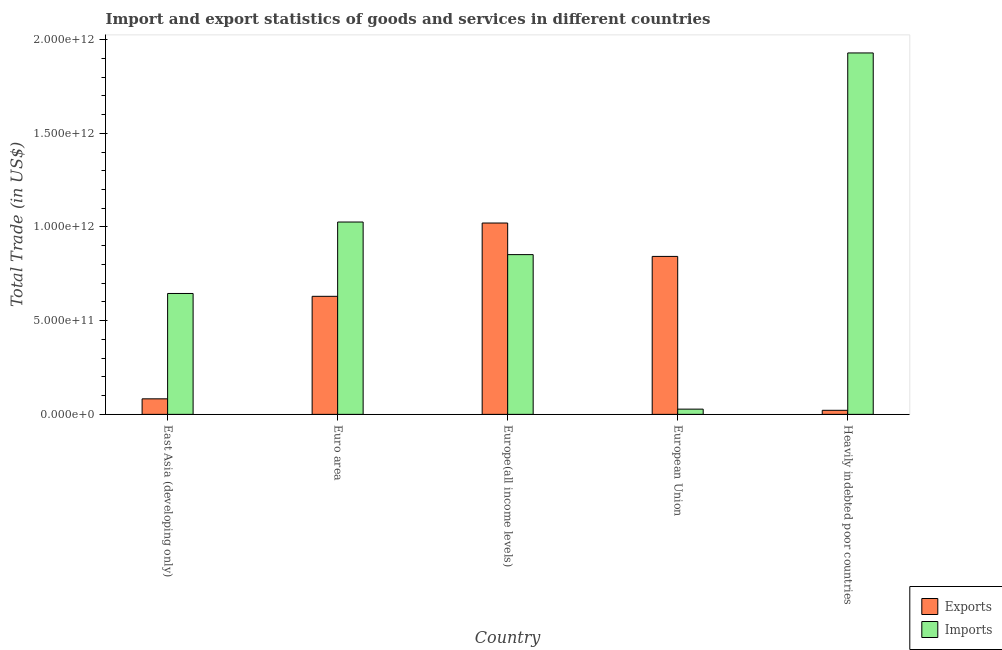How many groups of bars are there?
Ensure brevity in your answer.  5. Are the number of bars on each tick of the X-axis equal?
Your response must be concise. Yes. How many bars are there on the 4th tick from the left?
Keep it short and to the point. 2. How many bars are there on the 5th tick from the right?
Give a very brief answer. 2. In how many cases, is the number of bars for a given country not equal to the number of legend labels?
Ensure brevity in your answer.  0. What is the export of goods and services in Heavily indebted poor countries?
Ensure brevity in your answer.  2.17e+1. Across all countries, what is the maximum imports of goods and services?
Ensure brevity in your answer.  1.93e+12. Across all countries, what is the minimum export of goods and services?
Your answer should be very brief. 2.17e+1. In which country was the export of goods and services maximum?
Keep it short and to the point. Europe(all income levels). In which country was the export of goods and services minimum?
Offer a very short reply. Heavily indebted poor countries. What is the total export of goods and services in the graph?
Ensure brevity in your answer.  2.60e+12. What is the difference between the imports of goods and services in Euro area and that in Europe(all income levels)?
Your answer should be compact. 1.74e+11. What is the difference between the export of goods and services in East Asia (developing only) and the imports of goods and services in Europe(all income levels)?
Your response must be concise. -7.70e+11. What is the average imports of goods and services per country?
Provide a succinct answer. 8.96e+11. What is the difference between the export of goods and services and imports of goods and services in East Asia (developing only)?
Give a very brief answer. -5.62e+11. In how many countries, is the imports of goods and services greater than 1400000000000 US$?
Your answer should be very brief. 1. What is the ratio of the imports of goods and services in Euro area to that in European Union?
Your answer should be very brief. 36.71. Is the imports of goods and services in East Asia (developing only) less than that in Heavily indebted poor countries?
Your answer should be compact. Yes. Is the difference between the export of goods and services in European Union and Heavily indebted poor countries greater than the difference between the imports of goods and services in European Union and Heavily indebted poor countries?
Your answer should be compact. Yes. What is the difference between the highest and the second highest imports of goods and services?
Offer a very short reply. 9.02e+11. What is the difference between the highest and the lowest imports of goods and services?
Keep it short and to the point. 1.90e+12. In how many countries, is the imports of goods and services greater than the average imports of goods and services taken over all countries?
Provide a succinct answer. 2. What does the 1st bar from the left in Heavily indebted poor countries represents?
Offer a terse response. Exports. What does the 2nd bar from the right in Europe(all income levels) represents?
Make the answer very short. Exports. How many bars are there?
Your response must be concise. 10. How many countries are there in the graph?
Make the answer very short. 5. What is the difference between two consecutive major ticks on the Y-axis?
Give a very brief answer. 5.00e+11. Are the values on the major ticks of Y-axis written in scientific E-notation?
Provide a succinct answer. Yes. Does the graph contain any zero values?
Keep it short and to the point. No. Does the graph contain grids?
Provide a short and direct response. No. How are the legend labels stacked?
Your answer should be compact. Vertical. What is the title of the graph?
Provide a succinct answer. Import and export statistics of goods and services in different countries. What is the label or title of the Y-axis?
Provide a short and direct response. Total Trade (in US$). What is the Total Trade (in US$) in Exports in East Asia (developing only)?
Provide a succinct answer. 8.29e+1. What is the Total Trade (in US$) in Imports in East Asia (developing only)?
Your answer should be compact. 6.45e+11. What is the Total Trade (in US$) in Exports in Euro area?
Keep it short and to the point. 6.30e+11. What is the Total Trade (in US$) of Imports in Euro area?
Provide a short and direct response. 1.03e+12. What is the Total Trade (in US$) of Exports in Europe(all income levels)?
Offer a terse response. 1.02e+12. What is the Total Trade (in US$) in Imports in Europe(all income levels)?
Make the answer very short. 8.52e+11. What is the Total Trade (in US$) in Exports in European Union?
Offer a very short reply. 8.43e+11. What is the Total Trade (in US$) in Imports in European Union?
Provide a short and direct response. 2.80e+1. What is the Total Trade (in US$) in Exports in Heavily indebted poor countries?
Provide a succinct answer. 2.17e+1. What is the Total Trade (in US$) in Imports in Heavily indebted poor countries?
Provide a short and direct response. 1.93e+12. Across all countries, what is the maximum Total Trade (in US$) of Exports?
Make the answer very short. 1.02e+12. Across all countries, what is the maximum Total Trade (in US$) in Imports?
Offer a very short reply. 1.93e+12. Across all countries, what is the minimum Total Trade (in US$) of Exports?
Offer a terse response. 2.17e+1. Across all countries, what is the minimum Total Trade (in US$) in Imports?
Ensure brevity in your answer.  2.80e+1. What is the total Total Trade (in US$) in Exports in the graph?
Ensure brevity in your answer.  2.60e+12. What is the total Total Trade (in US$) of Imports in the graph?
Offer a terse response. 4.48e+12. What is the difference between the Total Trade (in US$) of Exports in East Asia (developing only) and that in Euro area?
Offer a terse response. -5.47e+11. What is the difference between the Total Trade (in US$) in Imports in East Asia (developing only) and that in Euro area?
Give a very brief answer. -3.81e+11. What is the difference between the Total Trade (in US$) in Exports in East Asia (developing only) and that in Europe(all income levels)?
Offer a very short reply. -9.38e+11. What is the difference between the Total Trade (in US$) in Imports in East Asia (developing only) and that in Europe(all income levels)?
Your response must be concise. -2.07e+11. What is the difference between the Total Trade (in US$) of Exports in East Asia (developing only) and that in European Union?
Keep it short and to the point. -7.60e+11. What is the difference between the Total Trade (in US$) in Imports in East Asia (developing only) and that in European Union?
Provide a succinct answer. 6.17e+11. What is the difference between the Total Trade (in US$) of Exports in East Asia (developing only) and that in Heavily indebted poor countries?
Your response must be concise. 6.12e+1. What is the difference between the Total Trade (in US$) in Imports in East Asia (developing only) and that in Heavily indebted poor countries?
Offer a terse response. -1.28e+12. What is the difference between the Total Trade (in US$) in Exports in Euro area and that in Europe(all income levels)?
Offer a terse response. -3.91e+11. What is the difference between the Total Trade (in US$) of Imports in Euro area and that in Europe(all income levels)?
Offer a terse response. 1.74e+11. What is the difference between the Total Trade (in US$) in Exports in Euro area and that in European Union?
Keep it short and to the point. -2.13e+11. What is the difference between the Total Trade (in US$) of Imports in Euro area and that in European Union?
Your answer should be compact. 9.99e+11. What is the difference between the Total Trade (in US$) in Exports in Euro area and that in Heavily indebted poor countries?
Your response must be concise. 6.08e+11. What is the difference between the Total Trade (in US$) in Imports in Euro area and that in Heavily indebted poor countries?
Give a very brief answer. -9.02e+11. What is the difference between the Total Trade (in US$) of Exports in Europe(all income levels) and that in European Union?
Your response must be concise. 1.78e+11. What is the difference between the Total Trade (in US$) in Imports in Europe(all income levels) and that in European Union?
Your answer should be compact. 8.25e+11. What is the difference between the Total Trade (in US$) in Exports in Europe(all income levels) and that in Heavily indebted poor countries?
Provide a short and direct response. 9.99e+11. What is the difference between the Total Trade (in US$) of Imports in Europe(all income levels) and that in Heavily indebted poor countries?
Your answer should be compact. -1.08e+12. What is the difference between the Total Trade (in US$) in Exports in European Union and that in Heavily indebted poor countries?
Keep it short and to the point. 8.21e+11. What is the difference between the Total Trade (in US$) in Imports in European Union and that in Heavily indebted poor countries?
Offer a terse response. -1.90e+12. What is the difference between the Total Trade (in US$) in Exports in East Asia (developing only) and the Total Trade (in US$) in Imports in Euro area?
Keep it short and to the point. -9.44e+11. What is the difference between the Total Trade (in US$) in Exports in East Asia (developing only) and the Total Trade (in US$) in Imports in Europe(all income levels)?
Offer a very short reply. -7.70e+11. What is the difference between the Total Trade (in US$) of Exports in East Asia (developing only) and the Total Trade (in US$) of Imports in European Union?
Give a very brief answer. 5.50e+1. What is the difference between the Total Trade (in US$) of Exports in East Asia (developing only) and the Total Trade (in US$) of Imports in Heavily indebted poor countries?
Offer a terse response. -1.85e+12. What is the difference between the Total Trade (in US$) of Exports in Euro area and the Total Trade (in US$) of Imports in Europe(all income levels)?
Give a very brief answer. -2.22e+11. What is the difference between the Total Trade (in US$) in Exports in Euro area and the Total Trade (in US$) in Imports in European Union?
Offer a terse response. 6.02e+11. What is the difference between the Total Trade (in US$) in Exports in Euro area and the Total Trade (in US$) in Imports in Heavily indebted poor countries?
Make the answer very short. -1.30e+12. What is the difference between the Total Trade (in US$) of Exports in Europe(all income levels) and the Total Trade (in US$) of Imports in European Union?
Provide a succinct answer. 9.93e+11. What is the difference between the Total Trade (in US$) in Exports in Europe(all income levels) and the Total Trade (in US$) in Imports in Heavily indebted poor countries?
Keep it short and to the point. -9.08e+11. What is the difference between the Total Trade (in US$) in Exports in European Union and the Total Trade (in US$) in Imports in Heavily indebted poor countries?
Provide a succinct answer. -1.09e+12. What is the average Total Trade (in US$) in Exports per country?
Your answer should be compact. 5.20e+11. What is the average Total Trade (in US$) in Imports per country?
Your response must be concise. 8.96e+11. What is the difference between the Total Trade (in US$) of Exports and Total Trade (in US$) of Imports in East Asia (developing only)?
Your response must be concise. -5.62e+11. What is the difference between the Total Trade (in US$) of Exports and Total Trade (in US$) of Imports in Euro area?
Ensure brevity in your answer.  -3.96e+11. What is the difference between the Total Trade (in US$) in Exports and Total Trade (in US$) in Imports in Europe(all income levels)?
Offer a terse response. 1.69e+11. What is the difference between the Total Trade (in US$) in Exports and Total Trade (in US$) in Imports in European Union?
Offer a terse response. 8.15e+11. What is the difference between the Total Trade (in US$) in Exports and Total Trade (in US$) in Imports in Heavily indebted poor countries?
Offer a terse response. -1.91e+12. What is the ratio of the Total Trade (in US$) in Exports in East Asia (developing only) to that in Euro area?
Offer a terse response. 0.13. What is the ratio of the Total Trade (in US$) in Imports in East Asia (developing only) to that in Euro area?
Offer a very short reply. 0.63. What is the ratio of the Total Trade (in US$) of Exports in East Asia (developing only) to that in Europe(all income levels)?
Keep it short and to the point. 0.08. What is the ratio of the Total Trade (in US$) of Imports in East Asia (developing only) to that in Europe(all income levels)?
Your answer should be very brief. 0.76. What is the ratio of the Total Trade (in US$) in Exports in East Asia (developing only) to that in European Union?
Keep it short and to the point. 0.1. What is the ratio of the Total Trade (in US$) in Imports in East Asia (developing only) to that in European Union?
Your answer should be very brief. 23.07. What is the ratio of the Total Trade (in US$) of Exports in East Asia (developing only) to that in Heavily indebted poor countries?
Your answer should be compact. 3.82. What is the ratio of the Total Trade (in US$) of Imports in East Asia (developing only) to that in Heavily indebted poor countries?
Give a very brief answer. 0.33. What is the ratio of the Total Trade (in US$) of Exports in Euro area to that in Europe(all income levels)?
Offer a very short reply. 0.62. What is the ratio of the Total Trade (in US$) in Imports in Euro area to that in Europe(all income levels)?
Provide a short and direct response. 1.2. What is the ratio of the Total Trade (in US$) of Exports in Euro area to that in European Union?
Offer a terse response. 0.75. What is the ratio of the Total Trade (in US$) in Imports in Euro area to that in European Union?
Provide a succinct answer. 36.71. What is the ratio of the Total Trade (in US$) in Exports in Euro area to that in Heavily indebted poor countries?
Keep it short and to the point. 29.01. What is the ratio of the Total Trade (in US$) in Imports in Euro area to that in Heavily indebted poor countries?
Your response must be concise. 0.53. What is the ratio of the Total Trade (in US$) of Exports in Europe(all income levels) to that in European Union?
Your answer should be very brief. 1.21. What is the ratio of the Total Trade (in US$) of Imports in Europe(all income levels) to that in European Union?
Offer a very short reply. 30.49. What is the ratio of the Total Trade (in US$) of Exports in Europe(all income levels) to that in Heavily indebted poor countries?
Provide a short and direct response. 47.03. What is the ratio of the Total Trade (in US$) in Imports in Europe(all income levels) to that in Heavily indebted poor countries?
Keep it short and to the point. 0.44. What is the ratio of the Total Trade (in US$) in Exports in European Union to that in Heavily indebted poor countries?
Your answer should be compact. 38.82. What is the ratio of the Total Trade (in US$) in Imports in European Union to that in Heavily indebted poor countries?
Your answer should be compact. 0.01. What is the difference between the highest and the second highest Total Trade (in US$) of Exports?
Provide a succinct answer. 1.78e+11. What is the difference between the highest and the second highest Total Trade (in US$) in Imports?
Keep it short and to the point. 9.02e+11. What is the difference between the highest and the lowest Total Trade (in US$) in Exports?
Your answer should be compact. 9.99e+11. What is the difference between the highest and the lowest Total Trade (in US$) of Imports?
Offer a terse response. 1.90e+12. 